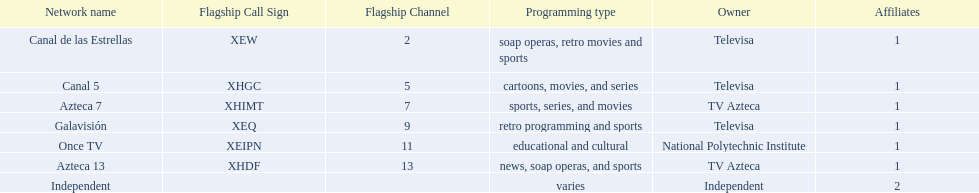What television stations are in morelos? Canal de las Estrellas, Canal 5, Azteca 7, Galavisión, Once TV, Azteca 13, Independent. Of those which network is owned by national polytechnic institute? Once TV. 